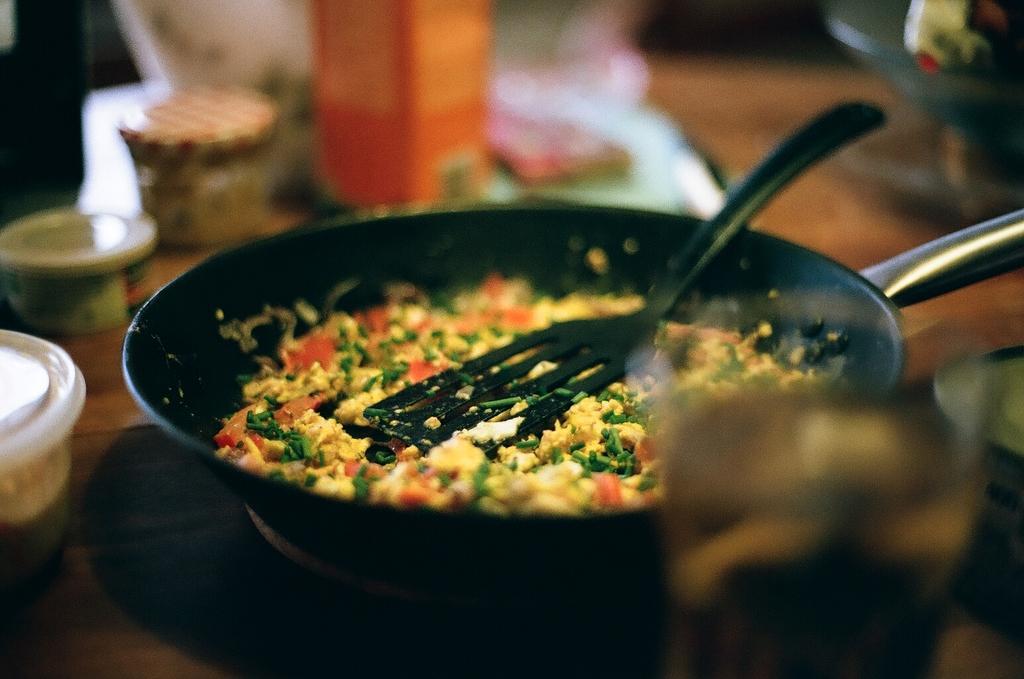Can you describe this image briefly? We can see food,container and some objects on wooden surface. 